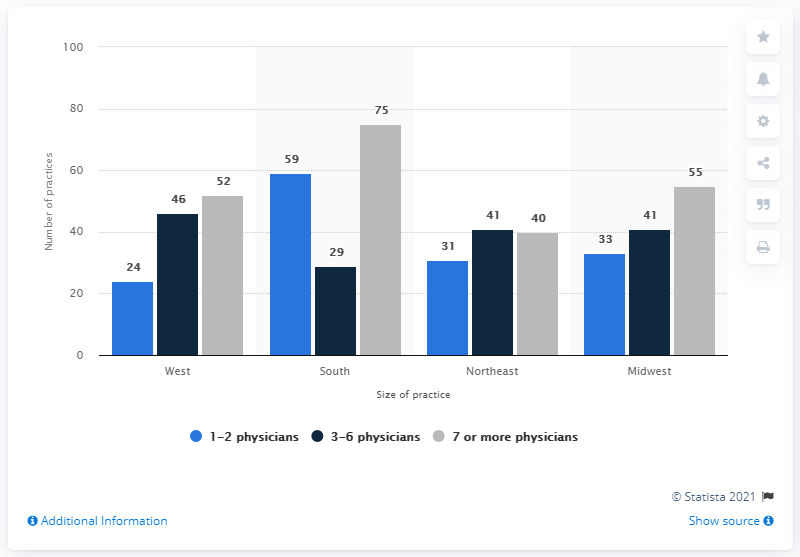Identify some key points in this picture. The color grey indicates the presence of at least seven physicians. There are 129 physicians in the Midwest. In 2013, there were 24 oncology practices located in the western part of the US. 